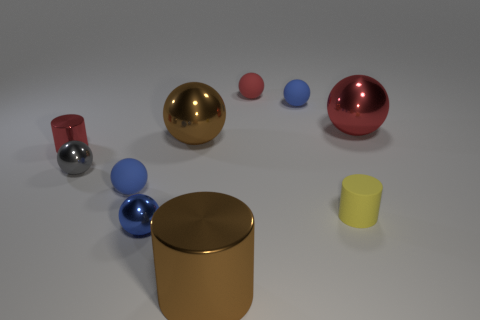Do the large red metallic object and the small red matte thing have the same shape?
Your answer should be compact. Yes. How many things are either shiny balls that are in front of the small gray metal sphere or small matte spheres?
Your response must be concise. 4. What is the size of the red cylinder that is the same material as the big brown cylinder?
Your answer should be very brief. Small. How many big things are the same color as the big metal cylinder?
Offer a terse response. 1. What number of big objects are either metal cylinders or shiny balls?
Ensure brevity in your answer.  3. There is a shiny sphere that is the same color as the small metallic cylinder; what size is it?
Provide a short and direct response. Large. Is there a small yellow cylinder made of the same material as the gray thing?
Offer a terse response. No. What is the blue sphere that is right of the tiny blue shiny sphere made of?
Keep it short and to the point. Rubber. There is a object left of the gray metallic ball; does it have the same color as the large metallic object on the right side of the tiny yellow rubber cylinder?
Make the answer very short. Yes. What color is the metallic cylinder that is the same size as the blue metallic thing?
Make the answer very short. Red. 